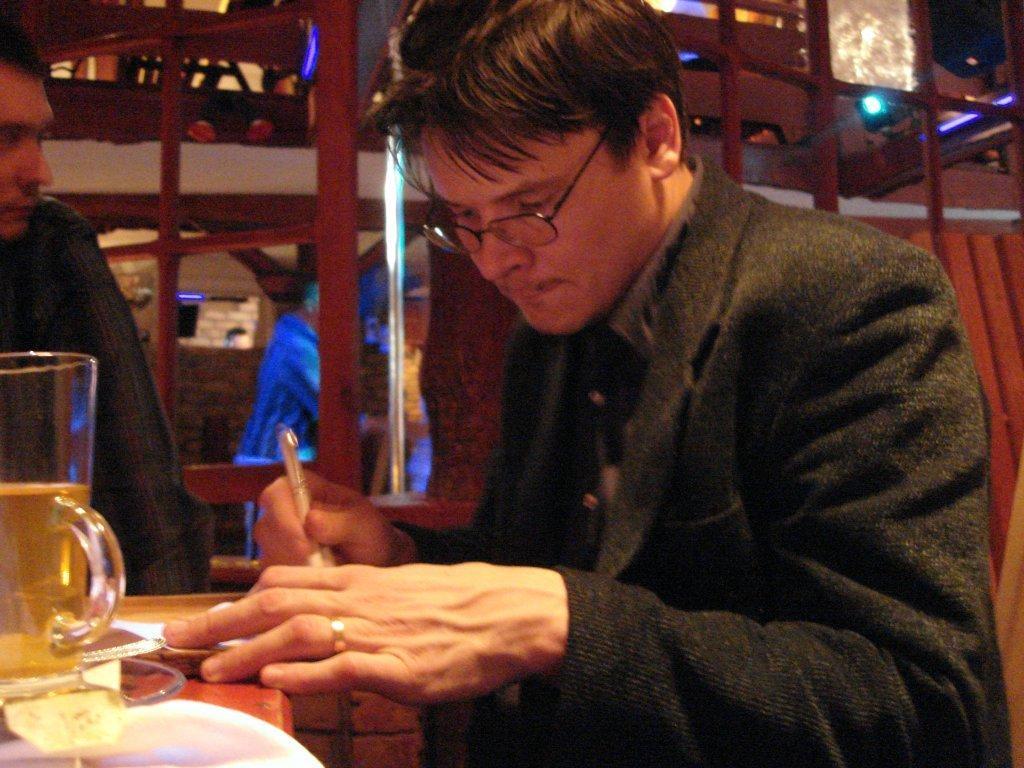In one or two sentences, can you explain what this image depicts? Here we can see two persons. He has spectacles and he is holding a pen with his hand. There is a glass on a platform. In the background we can see a person, wall, and lights. 